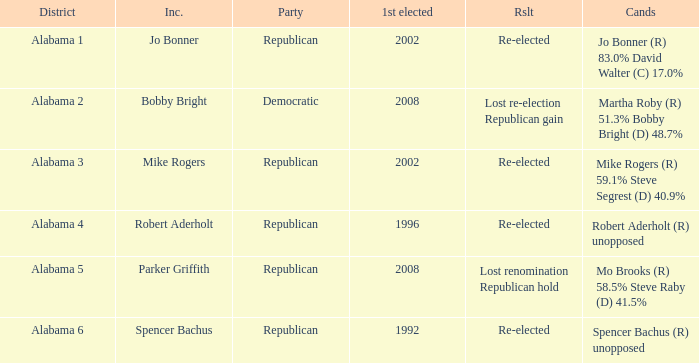Name the result for first elected being 1992 Re-elected. 